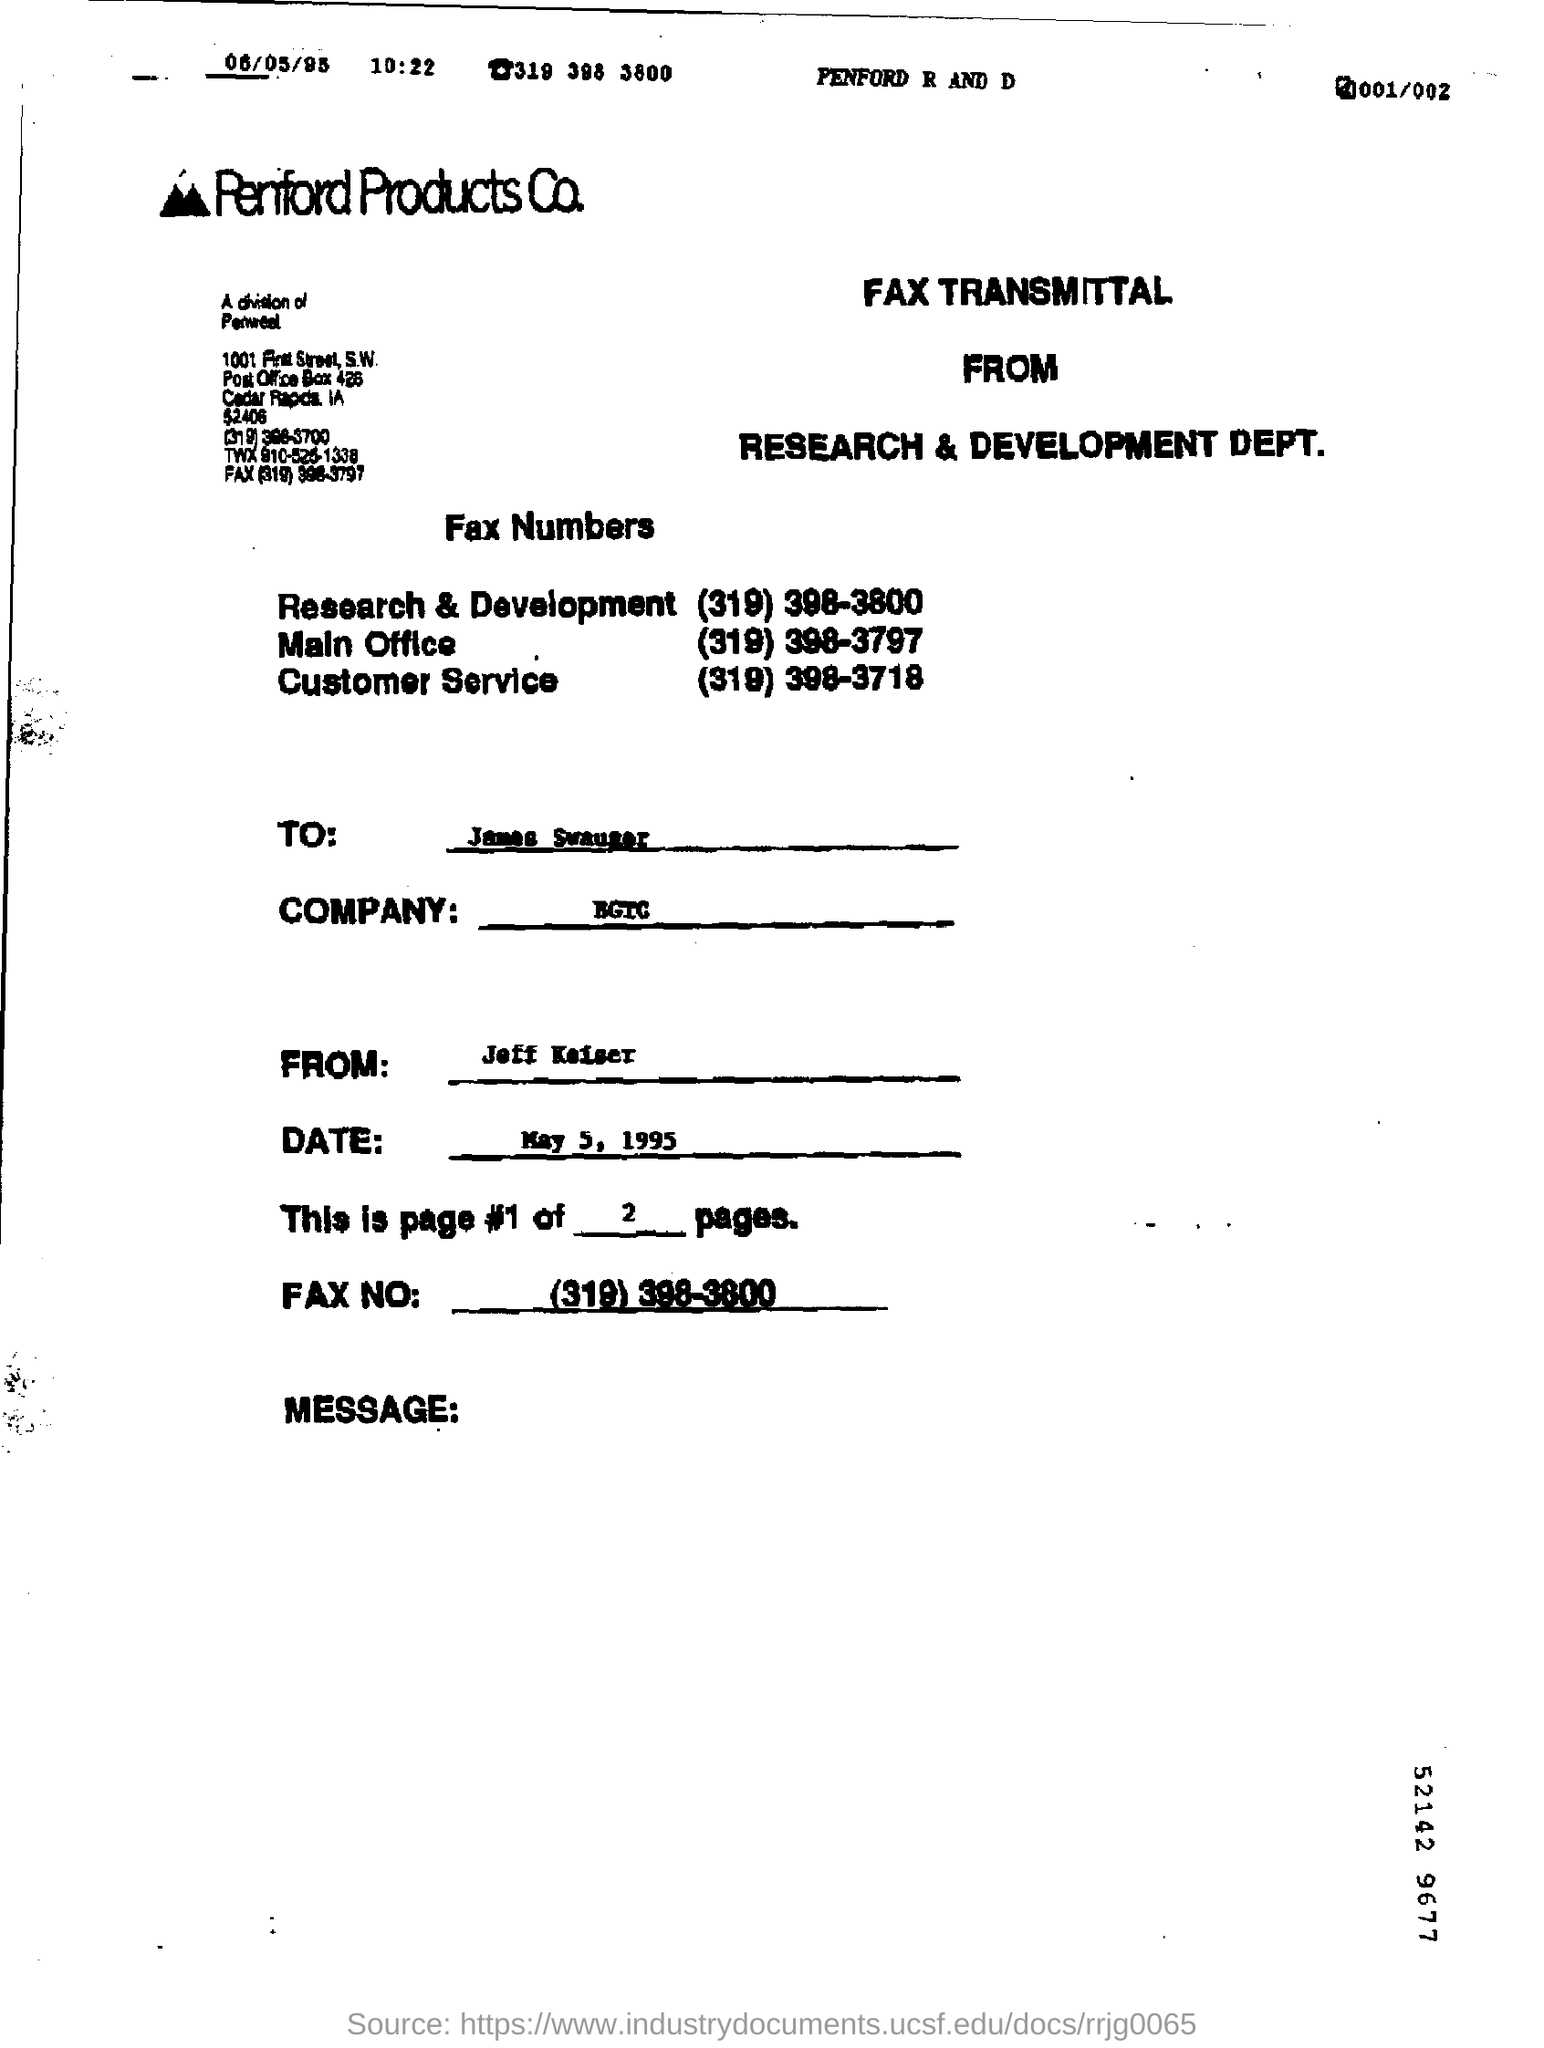Point out several critical features in this image. The fax number of the Research & Development department is (319) 398-3800. The customer service fax number is (319) 398-3718. 